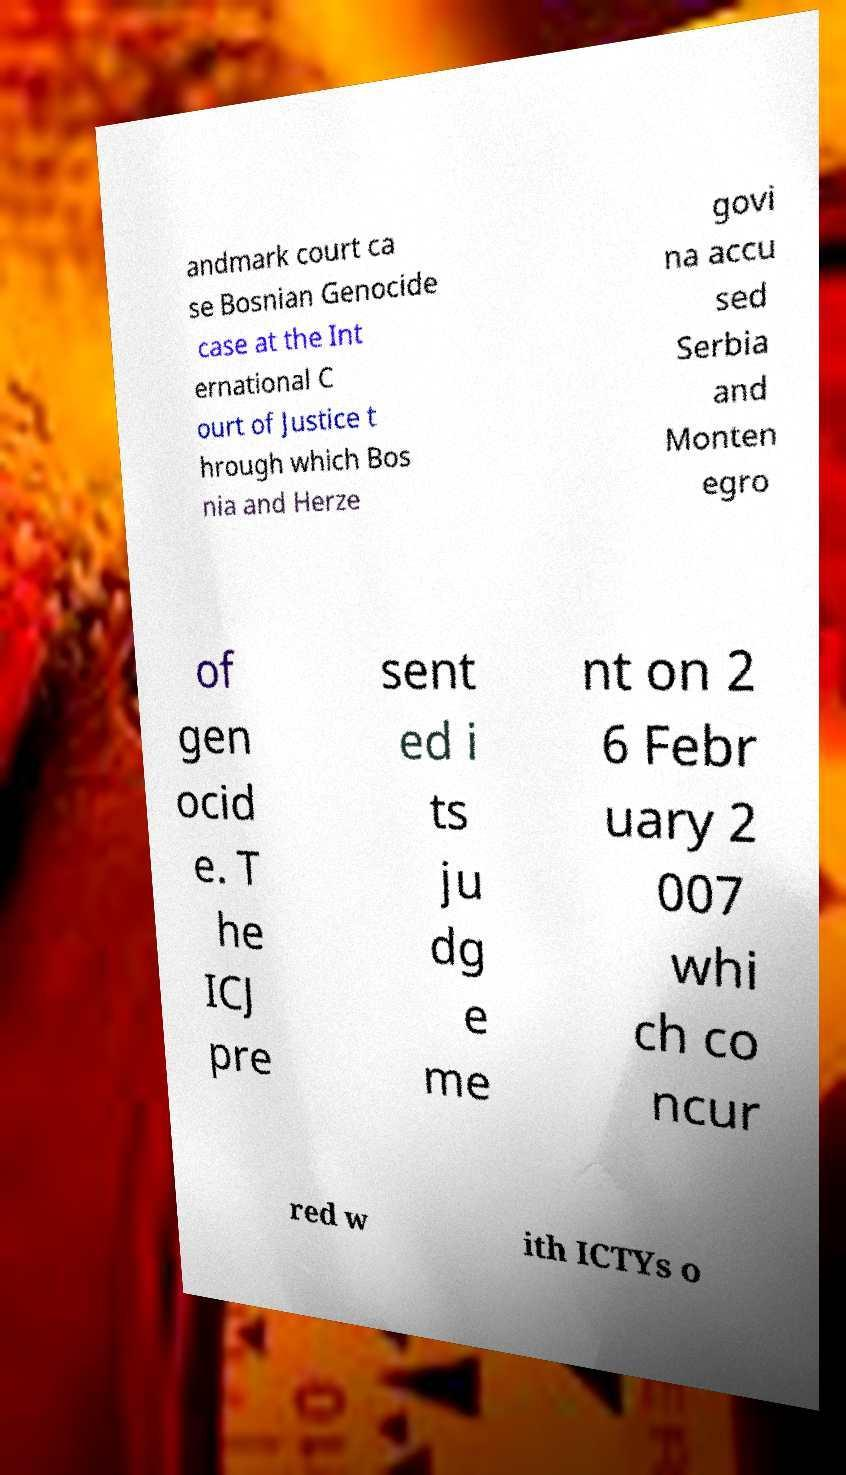Please read and relay the text visible in this image. What does it say? andmark court ca se Bosnian Genocide case at the Int ernational C ourt of Justice t hrough which Bos nia and Herze govi na accu sed Serbia and Monten egro of gen ocid e. T he ICJ pre sent ed i ts ju dg e me nt on 2 6 Febr uary 2 007 whi ch co ncur red w ith ICTYs o 